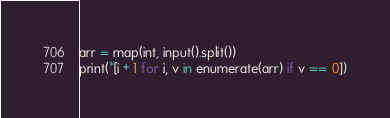Convert code to text. <code><loc_0><loc_0><loc_500><loc_500><_Python_>arr = map(int, input().split())
print(*[i + 1 for i, v in enumerate(arr) if v == 0])
</code> 